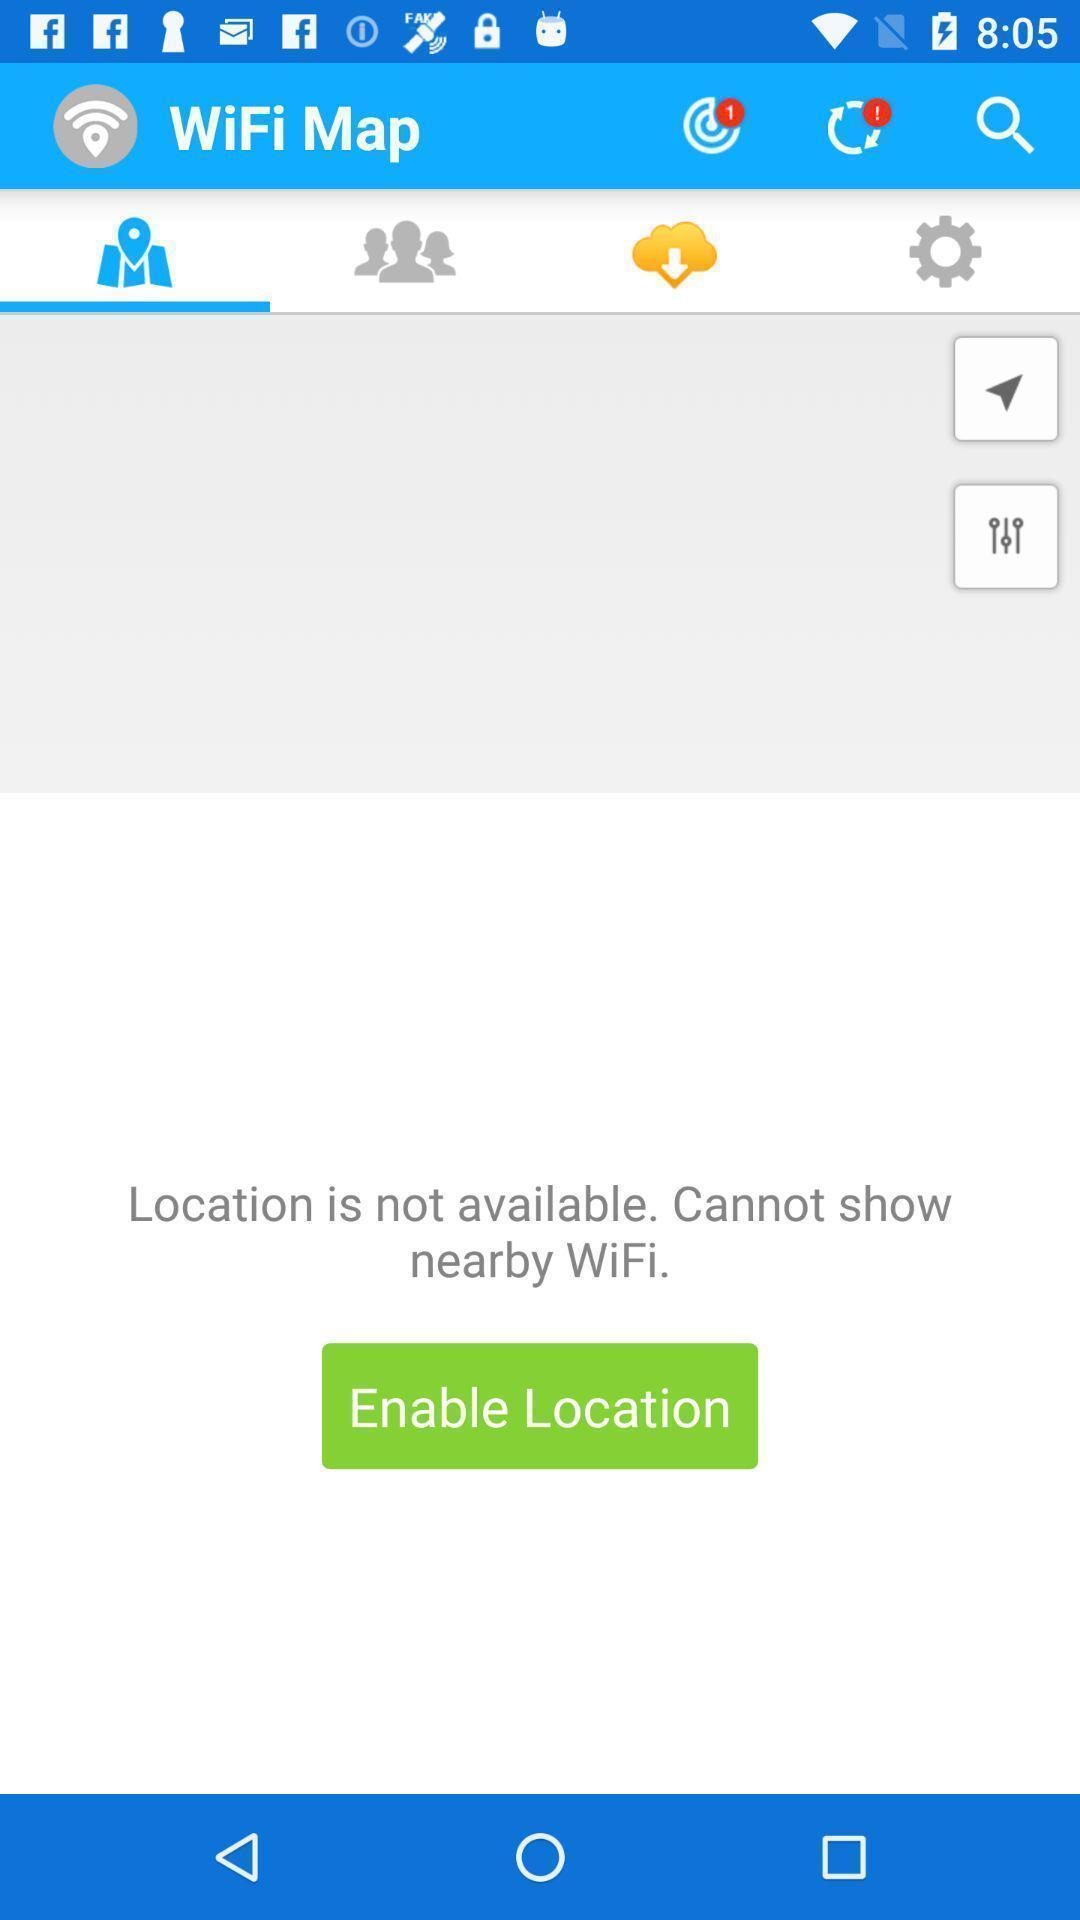Provide a description of this screenshot. Window displaying a page for wifi connection. 